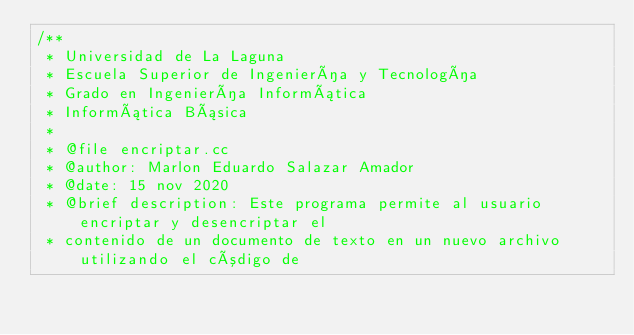Convert code to text. <code><loc_0><loc_0><loc_500><loc_500><_C++_>/**
 * Universidad de La Laguna
 * Escuela Superior de Ingeniería y Tecnología
 * Grado en Ingeniería Informática
 * Informática Básica
 *
 * @file encriptar.cc
 * @author: Marlon Eduardo Salazar Amador
 * @date: 15 nov 2020
 * @brief description: Este programa permite al usuario encriptar y desencriptar el
 * contenido de un documento de texto en un nuevo archivo utilizando el código de</code> 